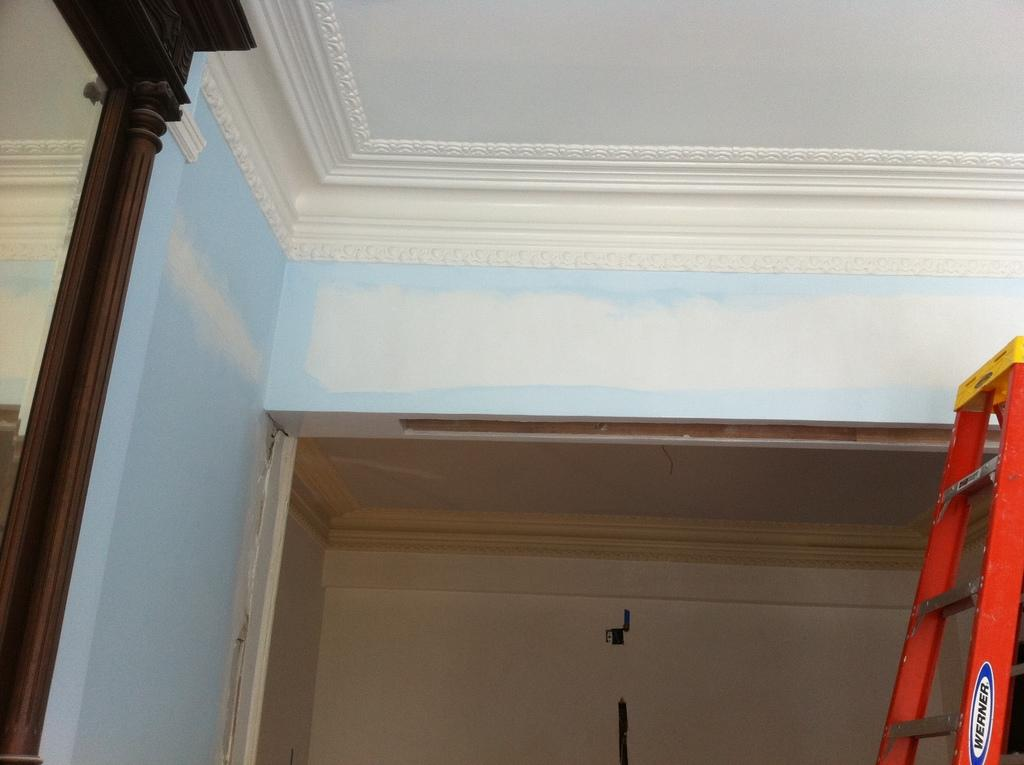What is located on the right side of the image? There is a ladder on the right side of the image. What can be seen at the top of the image? There is a wall and ceiling at the top of the image. What is on the left side of the image? There is a wooden object on the left side of the image, and there is also a wall on the left side. What is the main feature in the center of the image? There is a well in the center of the image. What type of celery can be seen growing near the well in the image? There is no celery present in the image; it features a ladder, wall, ceiling, wooden object, and a well. Can you tell me how many airports are visible in the image? There are no airports present in the image. 